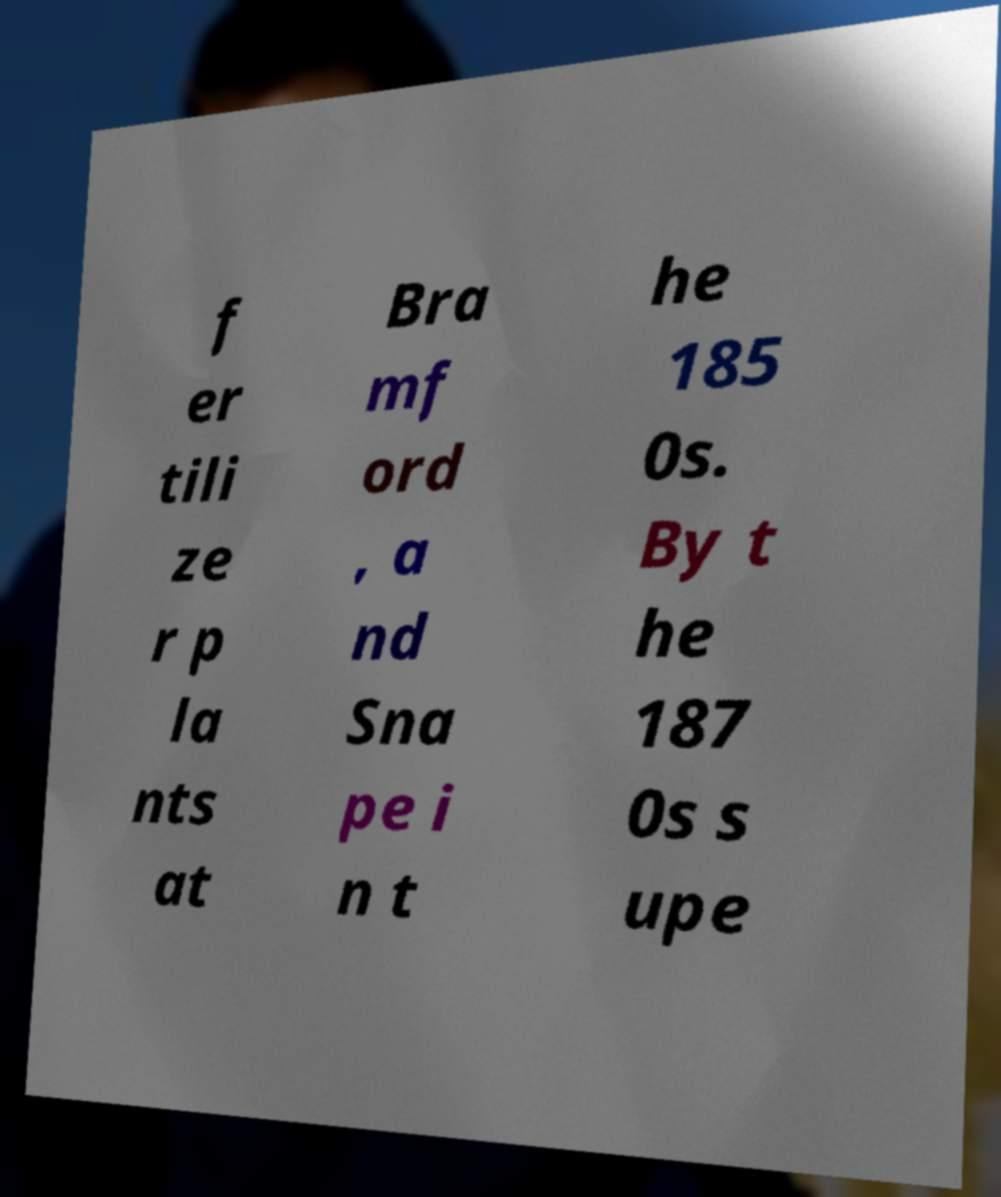For documentation purposes, I need the text within this image transcribed. Could you provide that? f er tili ze r p la nts at Bra mf ord , a nd Sna pe i n t he 185 0s. By t he 187 0s s upe 